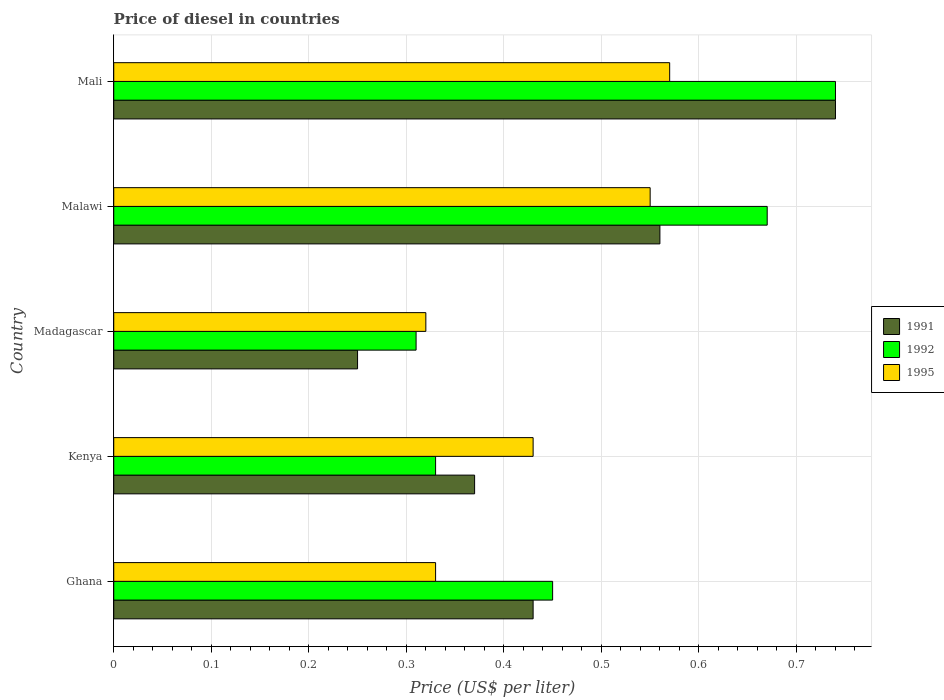How many groups of bars are there?
Offer a very short reply. 5. What is the label of the 3rd group of bars from the top?
Your answer should be very brief. Madagascar. In how many cases, is the number of bars for a given country not equal to the number of legend labels?
Offer a terse response. 0. What is the price of diesel in 1991 in Kenya?
Offer a very short reply. 0.37. Across all countries, what is the maximum price of diesel in 1992?
Your answer should be compact. 0.74. Across all countries, what is the minimum price of diesel in 1991?
Keep it short and to the point. 0.25. In which country was the price of diesel in 1991 maximum?
Your answer should be very brief. Mali. In which country was the price of diesel in 1995 minimum?
Your answer should be very brief. Madagascar. What is the total price of diesel in 1995 in the graph?
Keep it short and to the point. 2.2. What is the difference between the price of diesel in 1992 in Ghana and that in Madagascar?
Keep it short and to the point. 0.14. What is the difference between the price of diesel in 1991 in Ghana and the price of diesel in 1995 in Mali?
Your answer should be compact. -0.14. What is the average price of diesel in 1991 per country?
Your answer should be compact. 0.47. What is the difference between the price of diesel in 1995 and price of diesel in 1991 in Malawi?
Your answer should be very brief. -0.01. In how many countries, is the price of diesel in 1991 greater than 0.16 US$?
Give a very brief answer. 5. Is the price of diesel in 1992 in Ghana less than that in Malawi?
Offer a very short reply. Yes. Is the difference between the price of diesel in 1995 in Kenya and Madagascar greater than the difference between the price of diesel in 1991 in Kenya and Madagascar?
Your response must be concise. No. What is the difference between the highest and the second highest price of diesel in 1995?
Keep it short and to the point. 0.02. What is the difference between the highest and the lowest price of diesel in 1995?
Your answer should be compact. 0.25. In how many countries, is the price of diesel in 1992 greater than the average price of diesel in 1992 taken over all countries?
Keep it short and to the point. 2. What does the 2nd bar from the bottom in Malawi represents?
Give a very brief answer. 1992. Is it the case that in every country, the sum of the price of diesel in 1995 and price of diesel in 1991 is greater than the price of diesel in 1992?
Give a very brief answer. Yes. How many bars are there?
Make the answer very short. 15. Are all the bars in the graph horizontal?
Your response must be concise. Yes. How many countries are there in the graph?
Your answer should be very brief. 5. Does the graph contain any zero values?
Make the answer very short. No. Does the graph contain grids?
Keep it short and to the point. Yes. Where does the legend appear in the graph?
Provide a short and direct response. Center right. What is the title of the graph?
Give a very brief answer. Price of diesel in countries. Does "1987" appear as one of the legend labels in the graph?
Offer a very short reply. No. What is the label or title of the X-axis?
Provide a short and direct response. Price (US$ per liter). What is the Price (US$ per liter) in 1991 in Ghana?
Your response must be concise. 0.43. What is the Price (US$ per liter) in 1992 in Ghana?
Your answer should be compact. 0.45. What is the Price (US$ per liter) in 1995 in Ghana?
Your answer should be very brief. 0.33. What is the Price (US$ per liter) of 1991 in Kenya?
Your response must be concise. 0.37. What is the Price (US$ per liter) of 1992 in Kenya?
Provide a short and direct response. 0.33. What is the Price (US$ per liter) of 1995 in Kenya?
Offer a terse response. 0.43. What is the Price (US$ per liter) of 1991 in Madagascar?
Give a very brief answer. 0.25. What is the Price (US$ per liter) in 1992 in Madagascar?
Offer a very short reply. 0.31. What is the Price (US$ per liter) in 1995 in Madagascar?
Ensure brevity in your answer.  0.32. What is the Price (US$ per liter) in 1991 in Malawi?
Ensure brevity in your answer.  0.56. What is the Price (US$ per liter) in 1992 in Malawi?
Provide a short and direct response. 0.67. What is the Price (US$ per liter) of 1995 in Malawi?
Your answer should be very brief. 0.55. What is the Price (US$ per liter) of 1991 in Mali?
Provide a short and direct response. 0.74. What is the Price (US$ per liter) in 1992 in Mali?
Keep it short and to the point. 0.74. What is the Price (US$ per liter) in 1995 in Mali?
Give a very brief answer. 0.57. Across all countries, what is the maximum Price (US$ per liter) of 1991?
Your response must be concise. 0.74. Across all countries, what is the maximum Price (US$ per liter) of 1992?
Your answer should be very brief. 0.74. Across all countries, what is the maximum Price (US$ per liter) of 1995?
Provide a short and direct response. 0.57. Across all countries, what is the minimum Price (US$ per liter) in 1992?
Ensure brevity in your answer.  0.31. Across all countries, what is the minimum Price (US$ per liter) in 1995?
Provide a short and direct response. 0.32. What is the total Price (US$ per liter) of 1991 in the graph?
Give a very brief answer. 2.35. What is the total Price (US$ per liter) in 1995 in the graph?
Your answer should be compact. 2.2. What is the difference between the Price (US$ per liter) of 1991 in Ghana and that in Kenya?
Make the answer very short. 0.06. What is the difference between the Price (US$ per liter) of 1992 in Ghana and that in Kenya?
Offer a terse response. 0.12. What is the difference between the Price (US$ per liter) of 1995 in Ghana and that in Kenya?
Give a very brief answer. -0.1. What is the difference between the Price (US$ per liter) in 1991 in Ghana and that in Madagascar?
Provide a succinct answer. 0.18. What is the difference between the Price (US$ per liter) of 1992 in Ghana and that in Madagascar?
Provide a succinct answer. 0.14. What is the difference between the Price (US$ per liter) in 1995 in Ghana and that in Madagascar?
Keep it short and to the point. 0.01. What is the difference between the Price (US$ per liter) in 1991 in Ghana and that in Malawi?
Offer a terse response. -0.13. What is the difference between the Price (US$ per liter) in 1992 in Ghana and that in Malawi?
Ensure brevity in your answer.  -0.22. What is the difference between the Price (US$ per liter) in 1995 in Ghana and that in Malawi?
Your answer should be very brief. -0.22. What is the difference between the Price (US$ per liter) of 1991 in Ghana and that in Mali?
Your response must be concise. -0.31. What is the difference between the Price (US$ per liter) in 1992 in Ghana and that in Mali?
Offer a very short reply. -0.29. What is the difference between the Price (US$ per liter) of 1995 in Ghana and that in Mali?
Your answer should be compact. -0.24. What is the difference between the Price (US$ per liter) of 1991 in Kenya and that in Madagascar?
Provide a succinct answer. 0.12. What is the difference between the Price (US$ per liter) of 1995 in Kenya and that in Madagascar?
Provide a short and direct response. 0.11. What is the difference between the Price (US$ per liter) of 1991 in Kenya and that in Malawi?
Offer a very short reply. -0.19. What is the difference between the Price (US$ per liter) in 1992 in Kenya and that in Malawi?
Your answer should be compact. -0.34. What is the difference between the Price (US$ per liter) of 1995 in Kenya and that in Malawi?
Your answer should be compact. -0.12. What is the difference between the Price (US$ per liter) of 1991 in Kenya and that in Mali?
Provide a succinct answer. -0.37. What is the difference between the Price (US$ per liter) of 1992 in Kenya and that in Mali?
Make the answer very short. -0.41. What is the difference between the Price (US$ per liter) in 1995 in Kenya and that in Mali?
Provide a short and direct response. -0.14. What is the difference between the Price (US$ per liter) in 1991 in Madagascar and that in Malawi?
Provide a short and direct response. -0.31. What is the difference between the Price (US$ per liter) of 1992 in Madagascar and that in Malawi?
Provide a short and direct response. -0.36. What is the difference between the Price (US$ per liter) of 1995 in Madagascar and that in Malawi?
Provide a short and direct response. -0.23. What is the difference between the Price (US$ per liter) of 1991 in Madagascar and that in Mali?
Your answer should be compact. -0.49. What is the difference between the Price (US$ per liter) in 1992 in Madagascar and that in Mali?
Provide a short and direct response. -0.43. What is the difference between the Price (US$ per liter) in 1995 in Madagascar and that in Mali?
Keep it short and to the point. -0.25. What is the difference between the Price (US$ per liter) of 1991 in Malawi and that in Mali?
Provide a succinct answer. -0.18. What is the difference between the Price (US$ per liter) of 1992 in Malawi and that in Mali?
Provide a succinct answer. -0.07. What is the difference between the Price (US$ per liter) of 1995 in Malawi and that in Mali?
Your response must be concise. -0.02. What is the difference between the Price (US$ per liter) in 1991 in Ghana and the Price (US$ per liter) in 1992 in Kenya?
Make the answer very short. 0.1. What is the difference between the Price (US$ per liter) of 1992 in Ghana and the Price (US$ per liter) of 1995 in Kenya?
Provide a succinct answer. 0.02. What is the difference between the Price (US$ per liter) in 1991 in Ghana and the Price (US$ per liter) in 1992 in Madagascar?
Keep it short and to the point. 0.12. What is the difference between the Price (US$ per liter) in 1991 in Ghana and the Price (US$ per liter) in 1995 in Madagascar?
Provide a succinct answer. 0.11. What is the difference between the Price (US$ per liter) in 1992 in Ghana and the Price (US$ per liter) in 1995 in Madagascar?
Provide a short and direct response. 0.13. What is the difference between the Price (US$ per liter) in 1991 in Ghana and the Price (US$ per liter) in 1992 in Malawi?
Provide a succinct answer. -0.24. What is the difference between the Price (US$ per liter) in 1991 in Ghana and the Price (US$ per liter) in 1995 in Malawi?
Your answer should be very brief. -0.12. What is the difference between the Price (US$ per liter) in 1991 in Ghana and the Price (US$ per liter) in 1992 in Mali?
Ensure brevity in your answer.  -0.31. What is the difference between the Price (US$ per liter) in 1991 in Ghana and the Price (US$ per liter) in 1995 in Mali?
Provide a short and direct response. -0.14. What is the difference between the Price (US$ per liter) of 1992 in Ghana and the Price (US$ per liter) of 1995 in Mali?
Provide a succinct answer. -0.12. What is the difference between the Price (US$ per liter) of 1991 in Kenya and the Price (US$ per liter) of 1995 in Madagascar?
Offer a very short reply. 0.05. What is the difference between the Price (US$ per liter) in 1991 in Kenya and the Price (US$ per liter) in 1995 in Malawi?
Give a very brief answer. -0.18. What is the difference between the Price (US$ per liter) in 1992 in Kenya and the Price (US$ per liter) in 1995 in Malawi?
Your response must be concise. -0.22. What is the difference between the Price (US$ per liter) of 1991 in Kenya and the Price (US$ per liter) of 1992 in Mali?
Ensure brevity in your answer.  -0.37. What is the difference between the Price (US$ per liter) in 1992 in Kenya and the Price (US$ per liter) in 1995 in Mali?
Make the answer very short. -0.24. What is the difference between the Price (US$ per liter) in 1991 in Madagascar and the Price (US$ per liter) in 1992 in Malawi?
Offer a very short reply. -0.42. What is the difference between the Price (US$ per liter) of 1991 in Madagascar and the Price (US$ per liter) of 1995 in Malawi?
Your answer should be compact. -0.3. What is the difference between the Price (US$ per liter) in 1992 in Madagascar and the Price (US$ per liter) in 1995 in Malawi?
Your response must be concise. -0.24. What is the difference between the Price (US$ per liter) of 1991 in Madagascar and the Price (US$ per liter) of 1992 in Mali?
Give a very brief answer. -0.49. What is the difference between the Price (US$ per liter) of 1991 in Madagascar and the Price (US$ per liter) of 1995 in Mali?
Your answer should be very brief. -0.32. What is the difference between the Price (US$ per liter) of 1992 in Madagascar and the Price (US$ per liter) of 1995 in Mali?
Offer a terse response. -0.26. What is the difference between the Price (US$ per liter) of 1991 in Malawi and the Price (US$ per liter) of 1992 in Mali?
Offer a very short reply. -0.18. What is the difference between the Price (US$ per liter) of 1991 in Malawi and the Price (US$ per liter) of 1995 in Mali?
Your response must be concise. -0.01. What is the average Price (US$ per liter) in 1991 per country?
Give a very brief answer. 0.47. What is the average Price (US$ per liter) in 1992 per country?
Keep it short and to the point. 0.5. What is the average Price (US$ per liter) of 1995 per country?
Give a very brief answer. 0.44. What is the difference between the Price (US$ per liter) in 1991 and Price (US$ per liter) in 1992 in Ghana?
Provide a succinct answer. -0.02. What is the difference between the Price (US$ per liter) of 1992 and Price (US$ per liter) of 1995 in Ghana?
Make the answer very short. 0.12. What is the difference between the Price (US$ per liter) of 1991 and Price (US$ per liter) of 1995 in Kenya?
Offer a very short reply. -0.06. What is the difference between the Price (US$ per liter) in 1992 and Price (US$ per liter) in 1995 in Kenya?
Your answer should be compact. -0.1. What is the difference between the Price (US$ per liter) of 1991 and Price (US$ per liter) of 1992 in Madagascar?
Provide a succinct answer. -0.06. What is the difference between the Price (US$ per liter) in 1991 and Price (US$ per liter) in 1995 in Madagascar?
Your response must be concise. -0.07. What is the difference between the Price (US$ per liter) in 1992 and Price (US$ per liter) in 1995 in Madagascar?
Provide a succinct answer. -0.01. What is the difference between the Price (US$ per liter) of 1991 and Price (US$ per liter) of 1992 in Malawi?
Ensure brevity in your answer.  -0.11. What is the difference between the Price (US$ per liter) in 1991 and Price (US$ per liter) in 1995 in Malawi?
Provide a succinct answer. 0.01. What is the difference between the Price (US$ per liter) in 1992 and Price (US$ per liter) in 1995 in Malawi?
Offer a very short reply. 0.12. What is the difference between the Price (US$ per liter) of 1991 and Price (US$ per liter) of 1995 in Mali?
Your response must be concise. 0.17. What is the difference between the Price (US$ per liter) in 1992 and Price (US$ per liter) in 1995 in Mali?
Give a very brief answer. 0.17. What is the ratio of the Price (US$ per liter) of 1991 in Ghana to that in Kenya?
Ensure brevity in your answer.  1.16. What is the ratio of the Price (US$ per liter) of 1992 in Ghana to that in Kenya?
Your answer should be very brief. 1.36. What is the ratio of the Price (US$ per liter) in 1995 in Ghana to that in Kenya?
Ensure brevity in your answer.  0.77. What is the ratio of the Price (US$ per liter) in 1991 in Ghana to that in Madagascar?
Provide a short and direct response. 1.72. What is the ratio of the Price (US$ per liter) in 1992 in Ghana to that in Madagascar?
Your response must be concise. 1.45. What is the ratio of the Price (US$ per liter) of 1995 in Ghana to that in Madagascar?
Your response must be concise. 1.03. What is the ratio of the Price (US$ per liter) in 1991 in Ghana to that in Malawi?
Give a very brief answer. 0.77. What is the ratio of the Price (US$ per liter) of 1992 in Ghana to that in Malawi?
Your answer should be compact. 0.67. What is the ratio of the Price (US$ per liter) in 1995 in Ghana to that in Malawi?
Provide a succinct answer. 0.6. What is the ratio of the Price (US$ per liter) of 1991 in Ghana to that in Mali?
Your answer should be very brief. 0.58. What is the ratio of the Price (US$ per liter) of 1992 in Ghana to that in Mali?
Keep it short and to the point. 0.61. What is the ratio of the Price (US$ per liter) of 1995 in Ghana to that in Mali?
Offer a terse response. 0.58. What is the ratio of the Price (US$ per liter) in 1991 in Kenya to that in Madagascar?
Your answer should be compact. 1.48. What is the ratio of the Price (US$ per liter) of 1992 in Kenya to that in Madagascar?
Offer a very short reply. 1.06. What is the ratio of the Price (US$ per liter) in 1995 in Kenya to that in Madagascar?
Keep it short and to the point. 1.34. What is the ratio of the Price (US$ per liter) of 1991 in Kenya to that in Malawi?
Provide a short and direct response. 0.66. What is the ratio of the Price (US$ per liter) in 1992 in Kenya to that in Malawi?
Your answer should be very brief. 0.49. What is the ratio of the Price (US$ per liter) of 1995 in Kenya to that in Malawi?
Keep it short and to the point. 0.78. What is the ratio of the Price (US$ per liter) of 1991 in Kenya to that in Mali?
Give a very brief answer. 0.5. What is the ratio of the Price (US$ per liter) of 1992 in Kenya to that in Mali?
Keep it short and to the point. 0.45. What is the ratio of the Price (US$ per liter) of 1995 in Kenya to that in Mali?
Make the answer very short. 0.75. What is the ratio of the Price (US$ per liter) of 1991 in Madagascar to that in Malawi?
Provide a short and direct response. 0.45. What is the ratio of the Price (US$ per liter) of 1992 in Madagascar to that in Malawi?
Offer a terse response. 0.46. What is the ratio of the Price (US$ per liter) in 1995 in Madagascar to that in Malawi?
Your answer should be compact. 0.58. What is the ratio of the Price (US$ per liter) of 1991 in Madagascar to that in Mali?
Provide a succinct answer. 0.34. What is the ratio of the Price (US$ per liter) of 1992 in Madagascar to that in Mali?
Offer a terse response. 0.42. What is the ratio of the Price (US$ per liter) of 1995 in Madagascar to that in Mali?
Offer a very short reply. 0.56. What is the ratio of the Price (US$ per liter) of 1991 in Malawi to that in Mali?
Offer a terse response. 0.76. What is the ratio of the Price (US$ per liter) of 1992 in Malawi to that in Mali?
Provide a short and direct response. 0.91. What is the ratio of the Price (US$ per liter) in 1995 in Malawi to that in Mali?
Give a very brief answer. 0.96. What is the difference between the highest and the second highest Price (US$ per liter) of 1991?
Provide a succinct answer. 0.18. What is the difference between the highest and the second highest Price (US$ per liter) of 1992?
Keep it short and to the point. 0.07. What is the difference between the highest and the second highest Price (US$ per liter) in 1995?
Make the answer very short. 0.02. What is the difference between the highest and the lowest Price (US$ per liter) of 1991?
Offer a terse response. 0.49. What is the difference between the highest and the lowest Price (US$ per liter) in 1992?
Offer a very short reply. 0.43. 